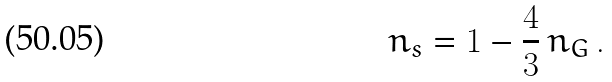<formula> <loc_0><loc_0><loc_500><loc_500>n _ { s } = 1 - \frac { 4 } { 3 } \, n _ { G } \, .</formula> 